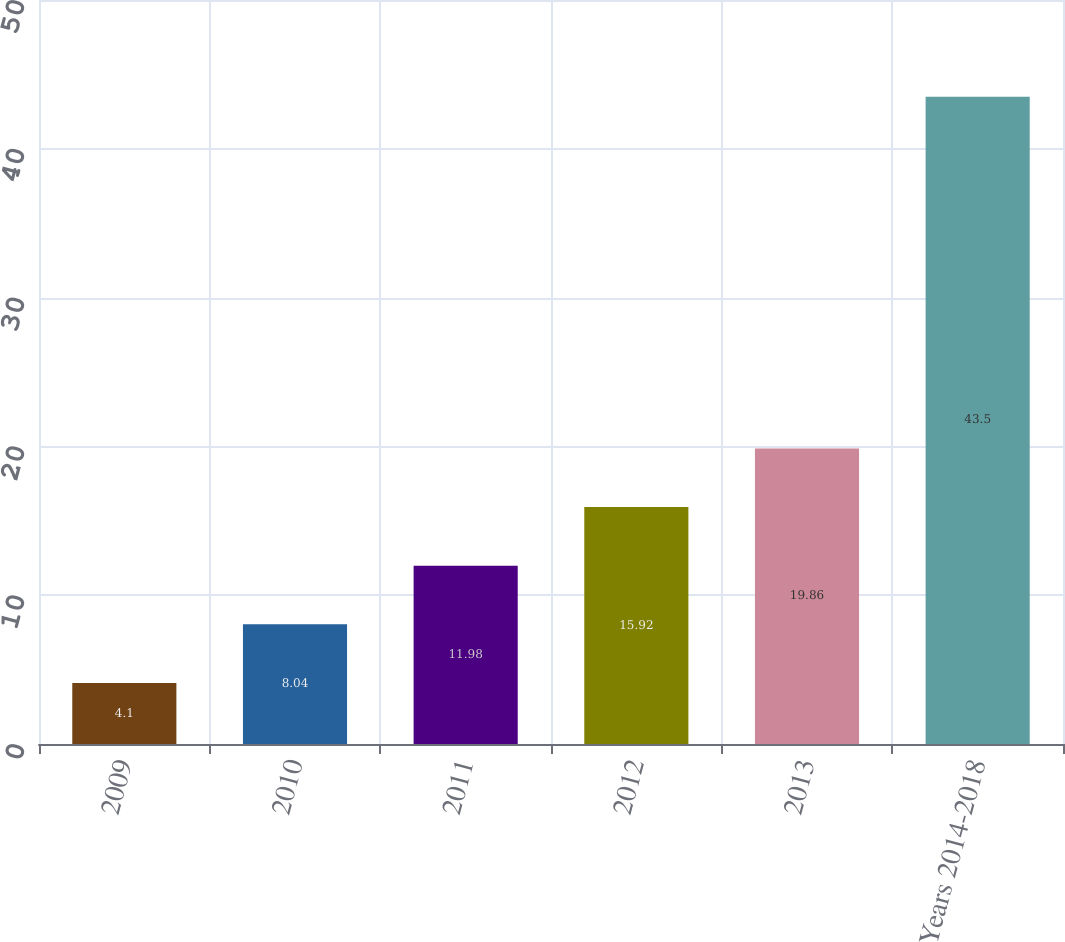Convert chart to OTSL. <chart><loc_0><loc_0><loc_500><loc_500><bar_chart><fcel>2009<fcel>2010<fcel>2011<fcel>2012<fcel>2013<fcel>Years 2014-2018<nl><fcel>4.1<fcel>8.04<fcel>11.98<fcel>15.92<fcel>19.86<fcel>43.5<nl></chart> 